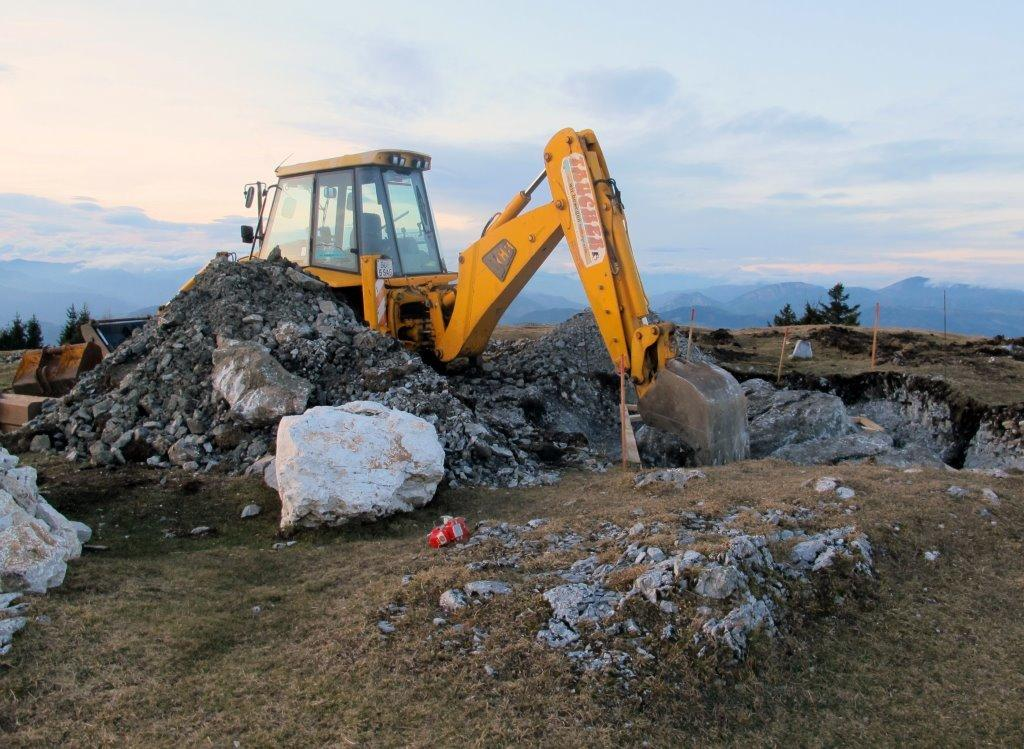What is located in the center of the image? There are stones and a yellow crane in the center of the image. What color is the crane in the image? The crane is yellow in color. What can be seen in the background of the image? The sky, clouds, hills, poles, and trees are visible in the background of the image. How many stamps are on the cent in the image? There is no cent or stamp present in the image. What type of birds can be seen flying in the image? There are no birds visible in the image. 